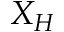<formula> <loc_0><loc_0><loc_500><loc_500>X _ { H }</formula> 